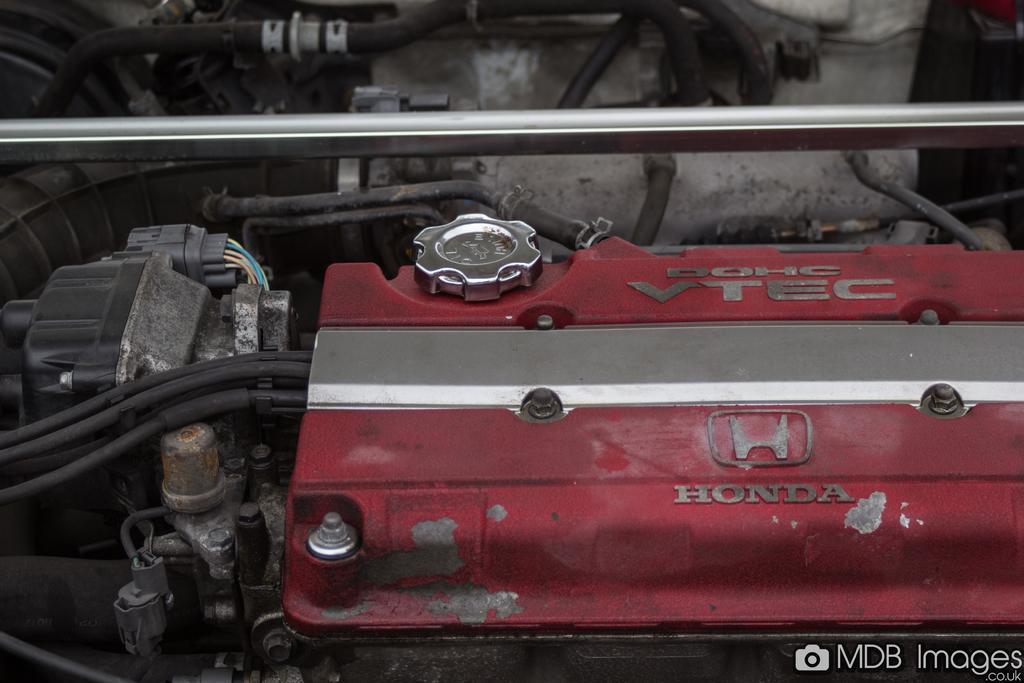Please provide a concise description of this image. In this image we can see an engine, here are the wires. 